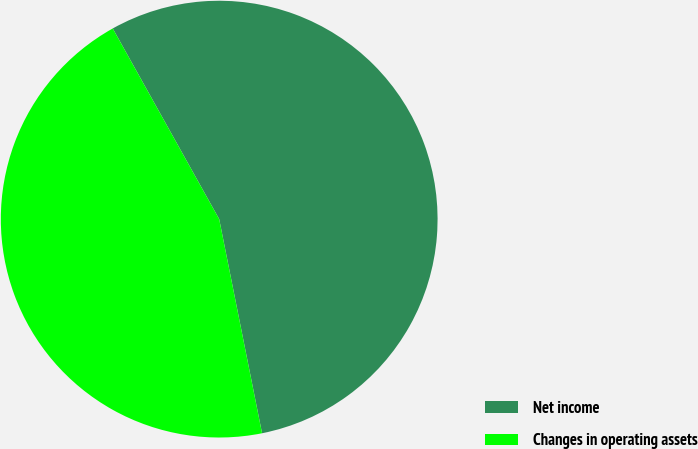<chart> <loc_0><loc_0><loc_500><loc_500><pie_chart><fcel>Net income<fcel>Changes in operating assets<nl><fcel>54.96%<fcel>45.04%<nl></chart> 